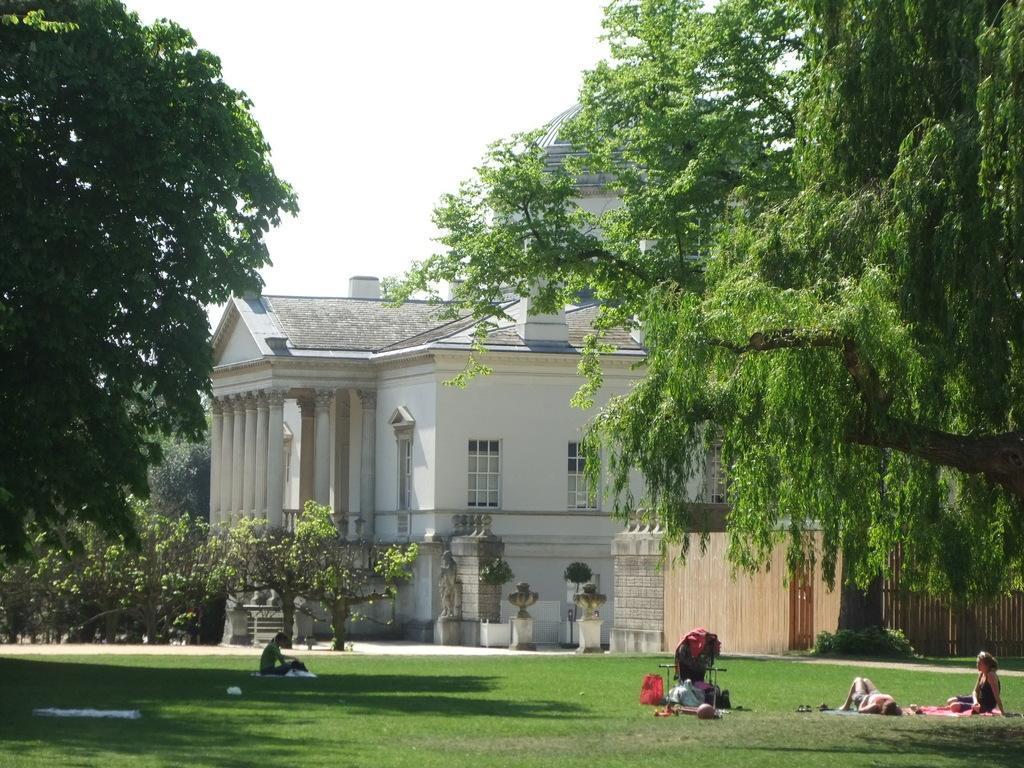Describe this image in one or two sentences. In the picture we can see some group of persons resting on ground which has lawn, there are some trees and in the background of the picture there is a building and clear sky. 